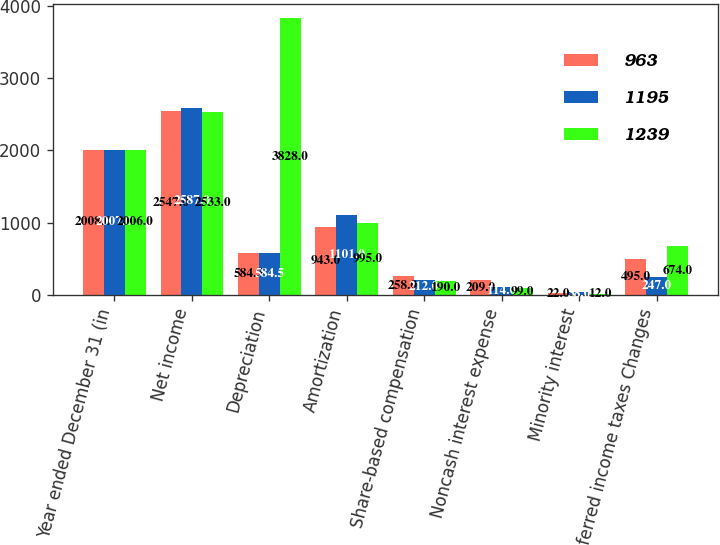Convert chart to OTSL. <chart><loc_0><loc_0><loc_500><loc_500><stacked_bar_chart><ecel><fcel>Year ended December 31 (in<fcel>Net income<fcel>Depreciation<fcel>Amortization<fcel>Share-based compensation<fcel>Noncash interest expense<fcel>Minority interest<fcel>Deferred income taxes Changes<nl><fcel>963<fcel>2008<fcel>2547<fcel>584.5<fcel>943<fcel>258<fcel>209<fcel>22<fcel>495<nl><fcel>1195<fcel>2007<fcel>2587<fcel>584.5<fcel>1101<fcel>212<fcel>114<fcel>38<fcel>247<nl><fcel>1239<fcel>2006<fcel>2533<fcel>3828<fcel>995<fcel>190<fcel>99<fcel>12<fcel>674<nl></chart> 